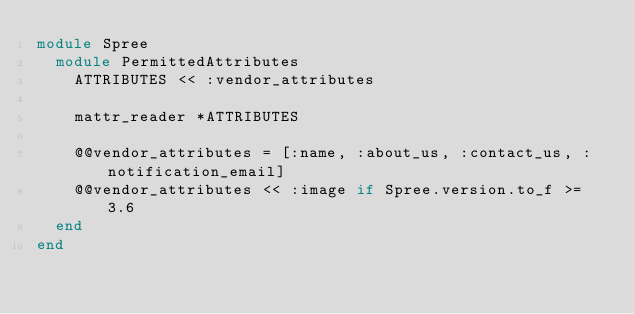Convert code to text. <code><loc_0><loc_0><loc_500><loc_500><_Ruby_>module Spree
  module PermittedAttributes
    ATTRIBUTES << :vendor_attributes

    mattr_reader *ATTRIBUTES

    @@vendor_attributes = [:name, :about_us, :contact_us, :notification_email]
    @@vendor_attributes << :image if Spree.version.to_f >= 3.6
  end
end
</code> 